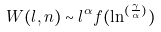<formula> <loc_0><loc_0><loc_500><loc_500>W ( l , n ) \sim l ^ { \alpha } f ( \ln ^ { ( \frac { \gamma } { \alpha } ) } )</formula> 